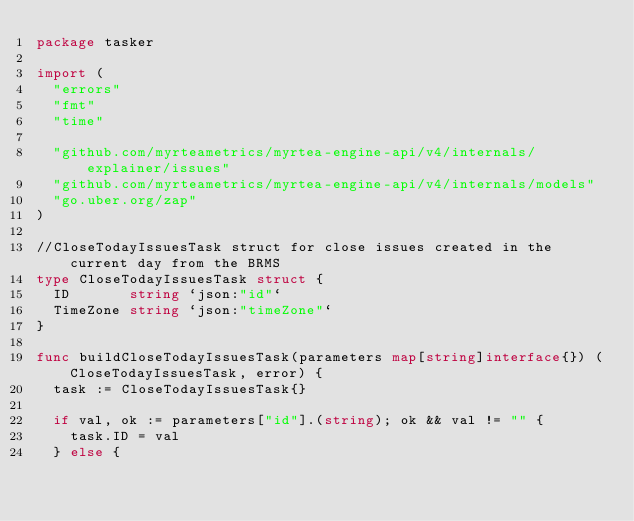Convert code to text. <code><loc_0><loc_0><loc_500><loc_500><_Go_>package tasker

import (
	"errors"
	"fmt"
	"time"

	"github.com/myrteametrics/myrtea-engine-api/v4/internals/explainer/issues"
	"github.com/myrteametrics/myrtea-engine-api/v4/internals/models"
	"go.uber.org/zap"
)

//CloseTodayIssuesTask struct for close issues created in the current day from the BRMS
type CloseTodayIssuesTask struct {
	ID       string `json:"id"`
	TimeZone string `json:"timeZone"`
}

func buildCloseTodayIssuesTask(parameters map[string]interface{}) (CloseTodayIssuesTask, error) {
	task := CloseTodayIssuesTask{}

	if val, ok := parameters["id"].(string); ok && val != "" {
		task.ID = val
	} else {</code> 